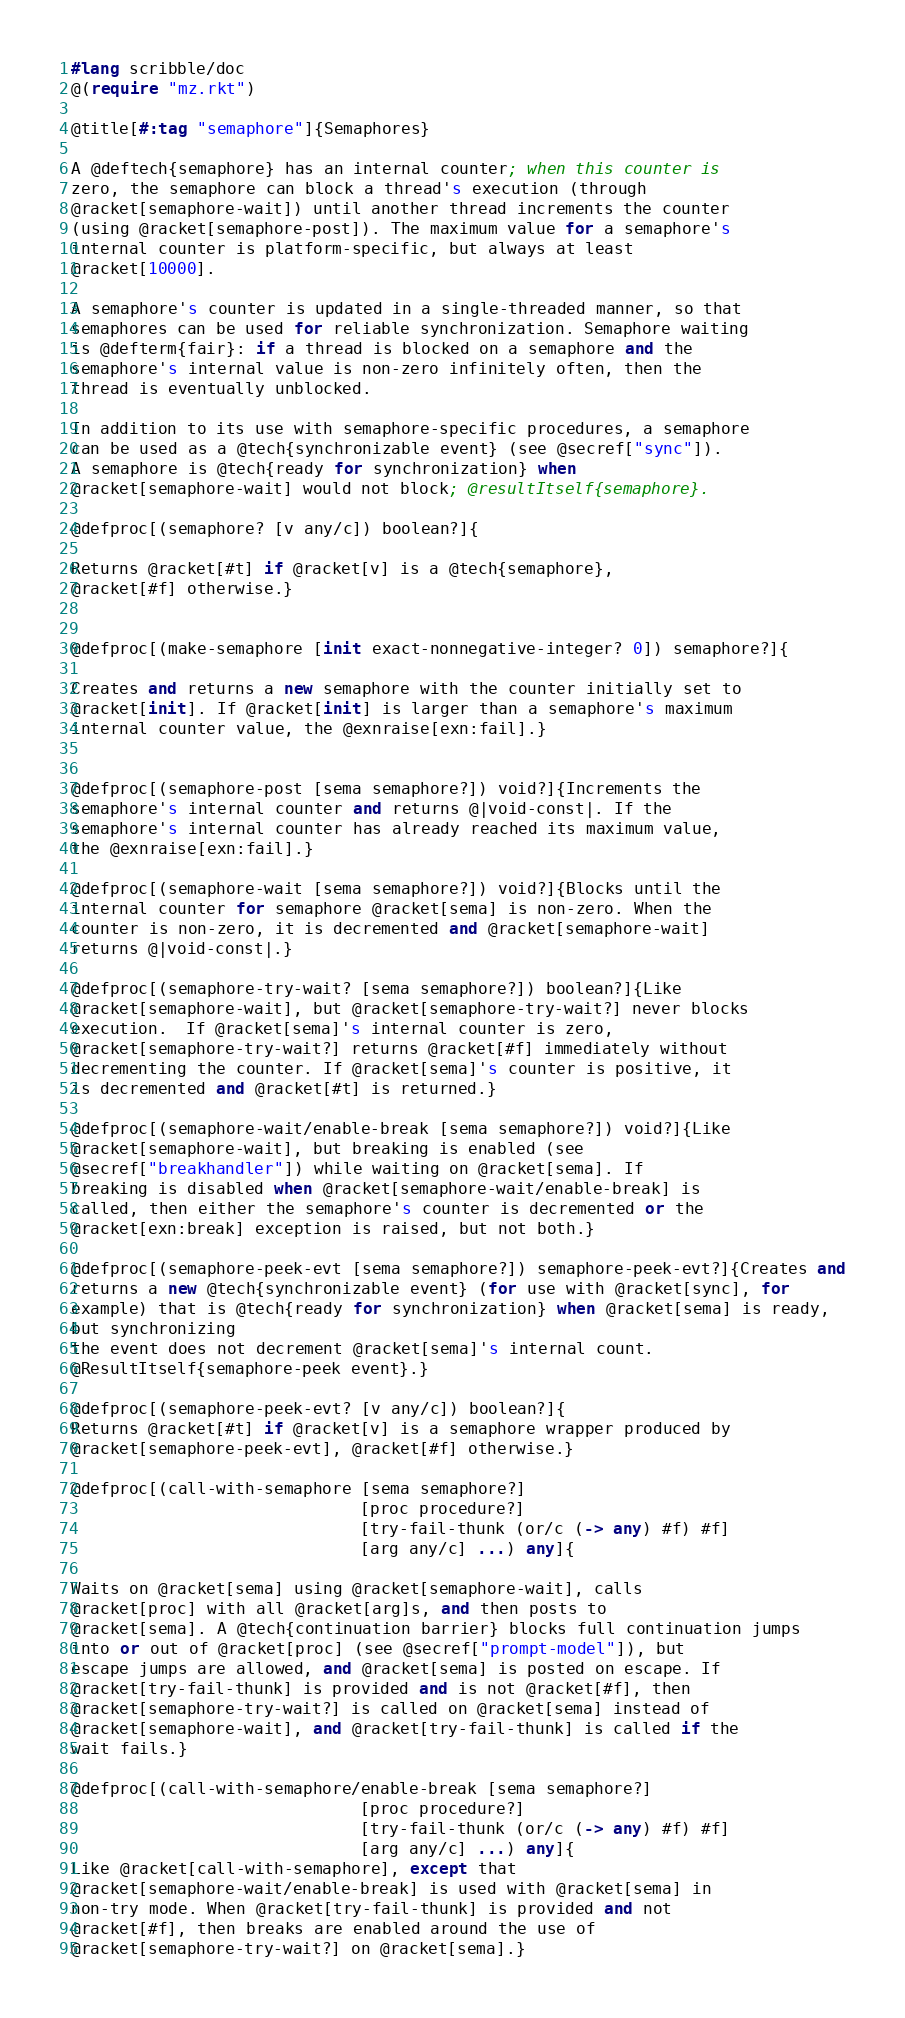<code> <loc_0><loc_0><loc_500><loc_500><_Racket_>#lang scribble/doc
@(require "mz.rkt")

@title[#:tag "semaphore"]{Semaphores}

A @deftech{semaphore} has an internal counter; when this counter is
zero, the semaphore can block a thread's execution (through
@racket[semaphore-wait]) until another thread increments the counter
(using @racket[semaphore-post]). The maximum value for a semaphore's
internal counter is platform-specific, but always at least
@racket[10000].

A semaphore's counter is updated in a single-threaded manner, so that
semaphores can be used for reliable synchronization. Semaphore waiting
is @defterm{fair}: if a thread is blocked on a semaphore and the
semaphore's internal value is non-zero infinitely often, then the
thread is eventually unblocked.

In addition to its use with semaphore-specific procedures, a semaphore
can be used as a @tech{synchronizable event} (see @secref["sync"]).
A semaphore is @tech{ready for synchronization} when
@racket[semaphore-wait] would not block; @resultItself{semaphore}.

@defproc[(semaphore? [v any/c]) boolean?]{

Returns @racket[#t] if @racket[v] is a @tech{semaphore}, 
@racket[#f] otherwise.}


@defproc[(make-semaphore [init exact-nonnegative-integer? 0]) semaphore?]{

Creates and returns a new semaphore with the counter initially set to
@racket[init]. If @racket[init] is larger than a semaphore's maximum
internal counter value, the @exnraise[exn:fail].}


@defproc[(semaphore-post [sema semaphore?]) void?]{Increments the
semaphore's internal counter and returns @|void-const|. If the
semaphore's internal counter has already reached its maximum value,
the @exnraise[exn:fail].}

@defproc[(semaphore-wait [sema semaphore?]) void?]{Blocks until the
internal counter for semaphore @racket[sema] is non-zero. When the
counter is non-zero, it is decremented and @racket[semaphore-wait]
returns @|void-const|.}

@defproc[(semaphore-try-wait? [sema semaphore?]) boolean?]{Like
@racket[semaphore-wait], but @racket[semaphore-try-wait?] never blocks
execution.  If @racket[sema]'s internal counter is zero,
@racket[semaphore-try-wait?] returns @racket[#f] immediately without
decrementing the counter. If @racket[sema]'s counter is positive, it
is decremented and @racket[#t] is returned.}

@defproc[(semaphore-wait/enable-break [sema semaphore?]) void?]{Like
@racket[semaphore-wait], but breaking is enabled (see
@secref["breakhandler"]) while waiting on @racket[sema]. If
breaking is disabled when @racket[semaphore-wait/enable-break] is
called, then either the semaphore's counter is decremented or the
@racket[exn:break] exception is raised, but not both.}

@defproc[(semaphore-peek-evt [sema semaphore?]) semaphore-peek-evt?]{Creates and
returns a new @tech{synchronizable event} (for use with @racket[sync], for
example) that is @tech{ready for synchronization} when @racket[sema] is ready,
but synchronizing
the event does not decrement @racket[sema]'s internal count.
@ResultItself{semaphore-peek event}.}

@defproc[(semaphore-peek-evt? [v any/c]) boolean?]{
Returns @racket[#t] if @racket[v] is a semaphore wrapper produced by
@racket[semaphore-peek-evt], @racket[#f] otherwise.}

@defproc[(call-with-semaphore [sema semaphore?]
                              [proc procedure?]
                              [try-fail-thunk (or/c (-> any) #f) #f]
                              [arg any/c] ...) any]{

Waits on @racket[sema] using @racket[semaphore-wait], calls
@racket[proc] with all @racket[arg]s, and then posts to
@racket[sema]. A @tech{continuation barrier} blocks full continuation jumps
into or out of @racket[proc] (see @secref["prompt-model"]), but
escape jumps are allowed, and @racket[sema] is posted on escape. If
@racket[try-fail-thunk] is provided and is not @racket[#f], then
@racket[semaphore-try-wait?] is called on @racket[sema] instead of
@racket[semaphore-wait], and @racket[try-fail-thunk] is called if the
wait fails.}

@defproc[(call-with-semaphore/enable-break [sema semaphore?]
                              [proc procedure?]
                              [try-fail-thunk (or/c (-> any) #f) #f]
                              [arg any/c] ...) any]{
Like @racket[call-with-semaphore], except that
@racket[semaphore-wait/enable-break] is used with @racket[sema] in
non-try mode. When @racket[try-fail-thunk] is provided and not
@racket[#f], then breaks are enabled around the use of
@racket[semaphore-try-wait?] on @racket[sema].}
</code> 